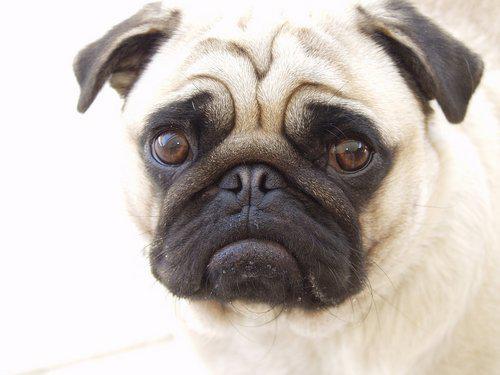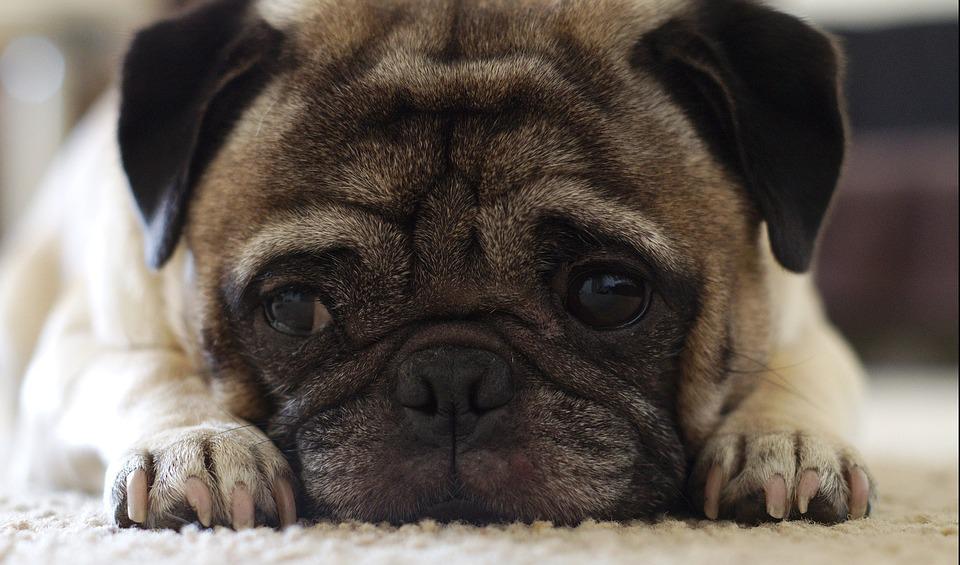The first image is the image on the left, the second image is the image on the right. For the images displayed, is the sentence "Whites of the eyes are very visible on the dog on the left." factually correct? Answer yes or no. No. 